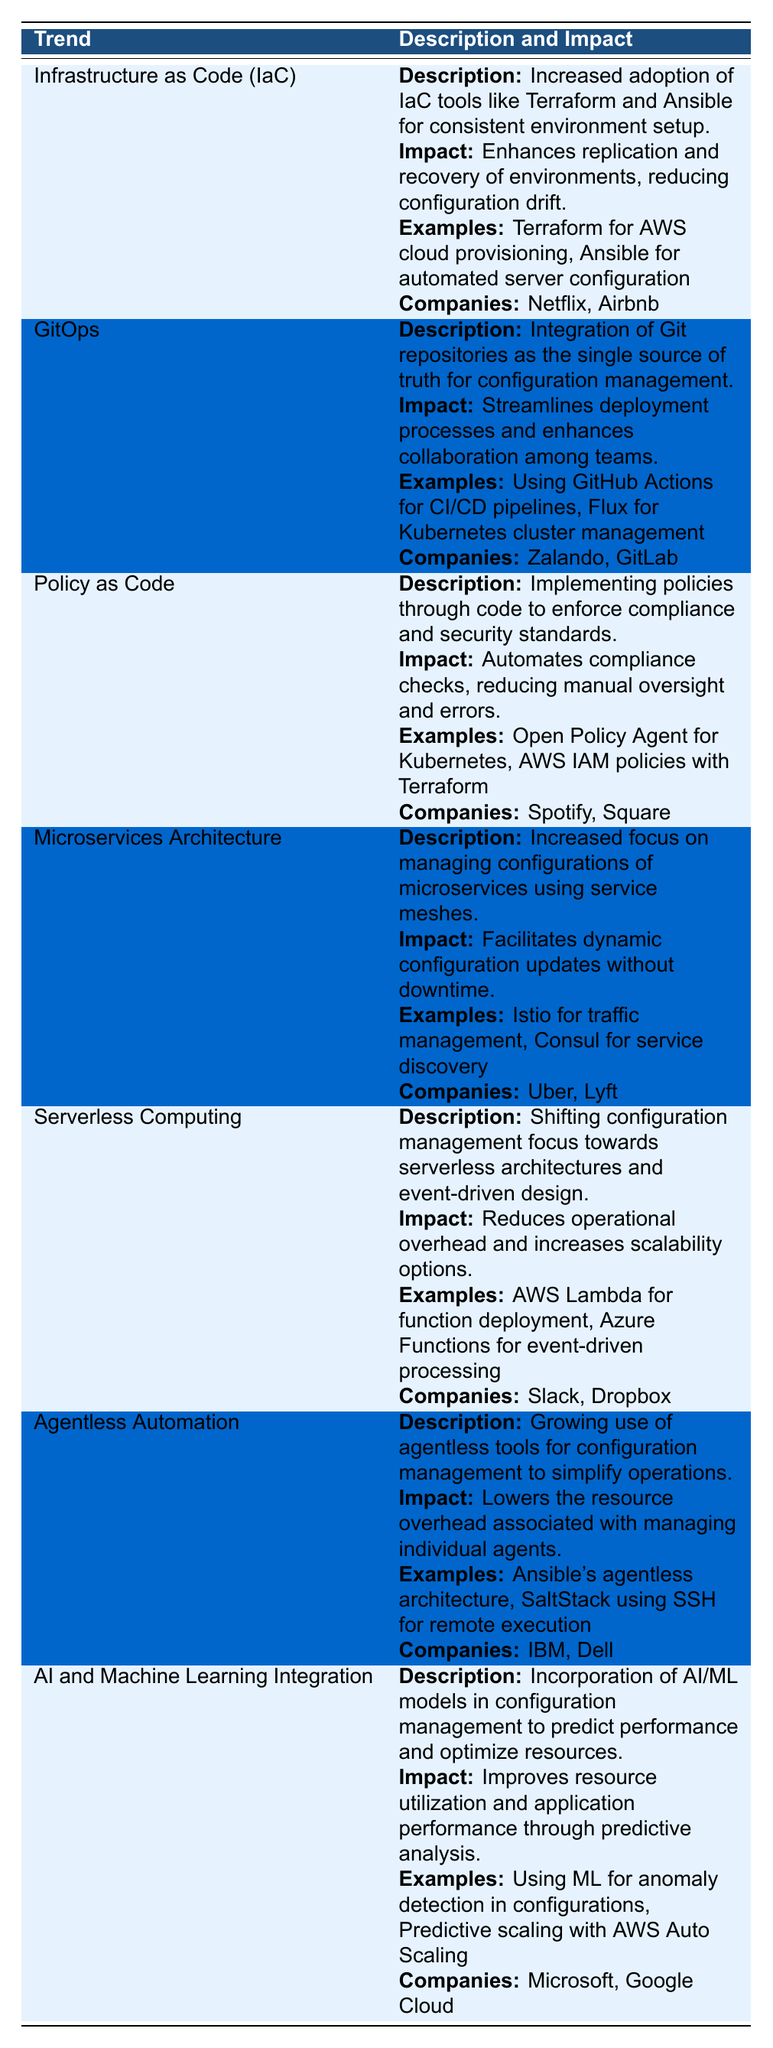What trend focuses on managing configurations of microservices? The table specifically mentions "Microservices Architecture" as a trend that focuses on this area, with details provided in its respective section.
Answer: Microservices Architecture Which companies are associated with the trend "Infrastructure as Code (IaC)"? The entries for "Infrastructure as Code (IaC)" in the table list "Netflix" and "Airbnb" as the companies using this trend.
Answer: Netflix, Airbnb Is "AI and Machine Learning Integration" described as automating compliance checks? The description of "AI and Machine Learning Integration" focuses on predicting performance and optimizing resources, rather than on compliance checks. This task is related to the trend "Policy as Code."
Answer: No What example is provided for "Serverless Computing"? The section on "Serverless Computing" lists "AWS Lambda for function deployment" as an example demonstrating the trend.
Answer: AWS Lambda for function deployment Which trends utilize Git as part of their process? The only trend that directly involves Git is "GitOps," as described in the table with its focus on Git repositories as the single source of truth.
Answer: GitOps How many companies are listed under the trend "Agentless Automation"? The section for "Agentless Automation" lists "IBM" and "Dell," giving a total of 2 companies mentioned.
Answer: 2 What is the primary impact of "Policy as Code"? The table states that "Policy as Code" automates compliance checks, thereby reducing manual oversight and errors, highlighting its primary impact.
Answer: Automates compliance checks Which trend includes examples related to event-driven processing? The trend "Serverless Computing" includes examples associated with event-driven processing, specifically mentioning "Azure Functions."
Answer: Serverless Computing Are the companies listed under "Microservices Architecture" different from those under "Serverless Computing"? "Microservices Architecture" lists "Uber" and "Lyft," while "Serverless Computing" lists "Slack" and "Dropbox," indicating different companies under each trend.
Answer: Yes What do "AI and Machine Learning Integration" and "Agentless Automation" have in common based on their descriptions? Both trends aim to improve operational efficiency; "AI and Machine Learning Integration" seeks to optimize resources and performance, while "Agentless Automation" simplifies operations by reducing resource overhead.
Answer: Improve operational efficiency 